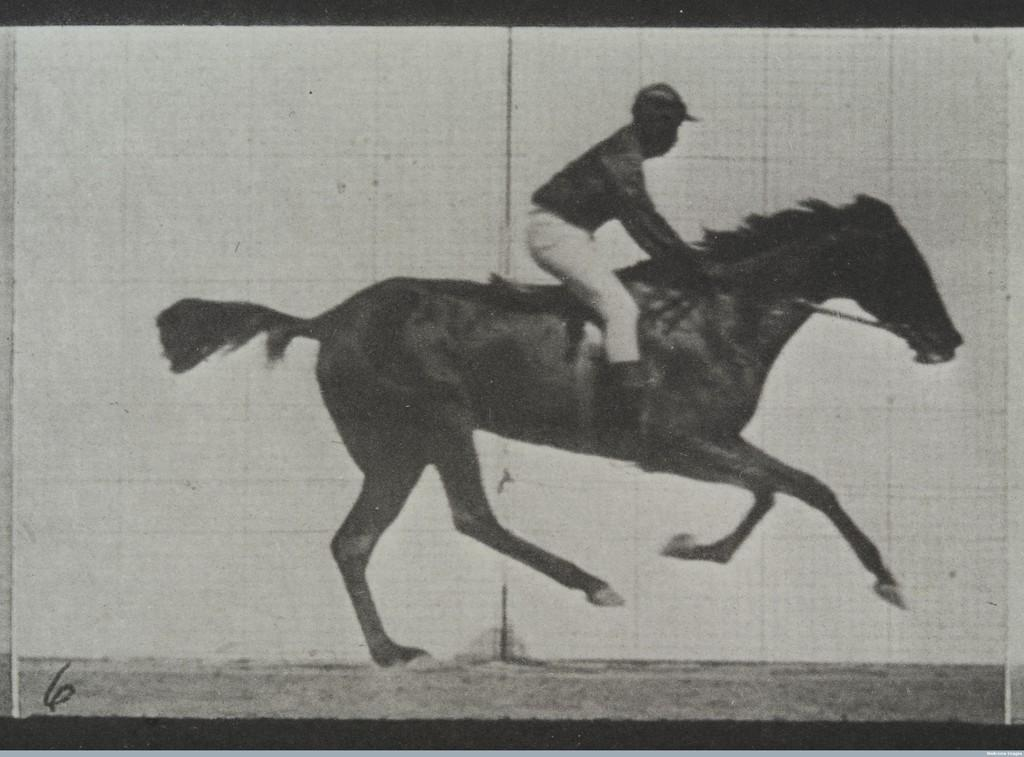Who is the main subject in the image? There is a man in the image. What is the man doing in the image? The man is riding a horse. What is the position of the horse in the image? The horse is on the ground. What can be seen in the background of the image? The sky is visible in the background of the image. How many pies are being baked by the man in the image? There are no pies present in the image; the man is riding a horse. What type of houses can be seen in the background of the image? There are no houses visible in the background of the image; only the sky is present. 